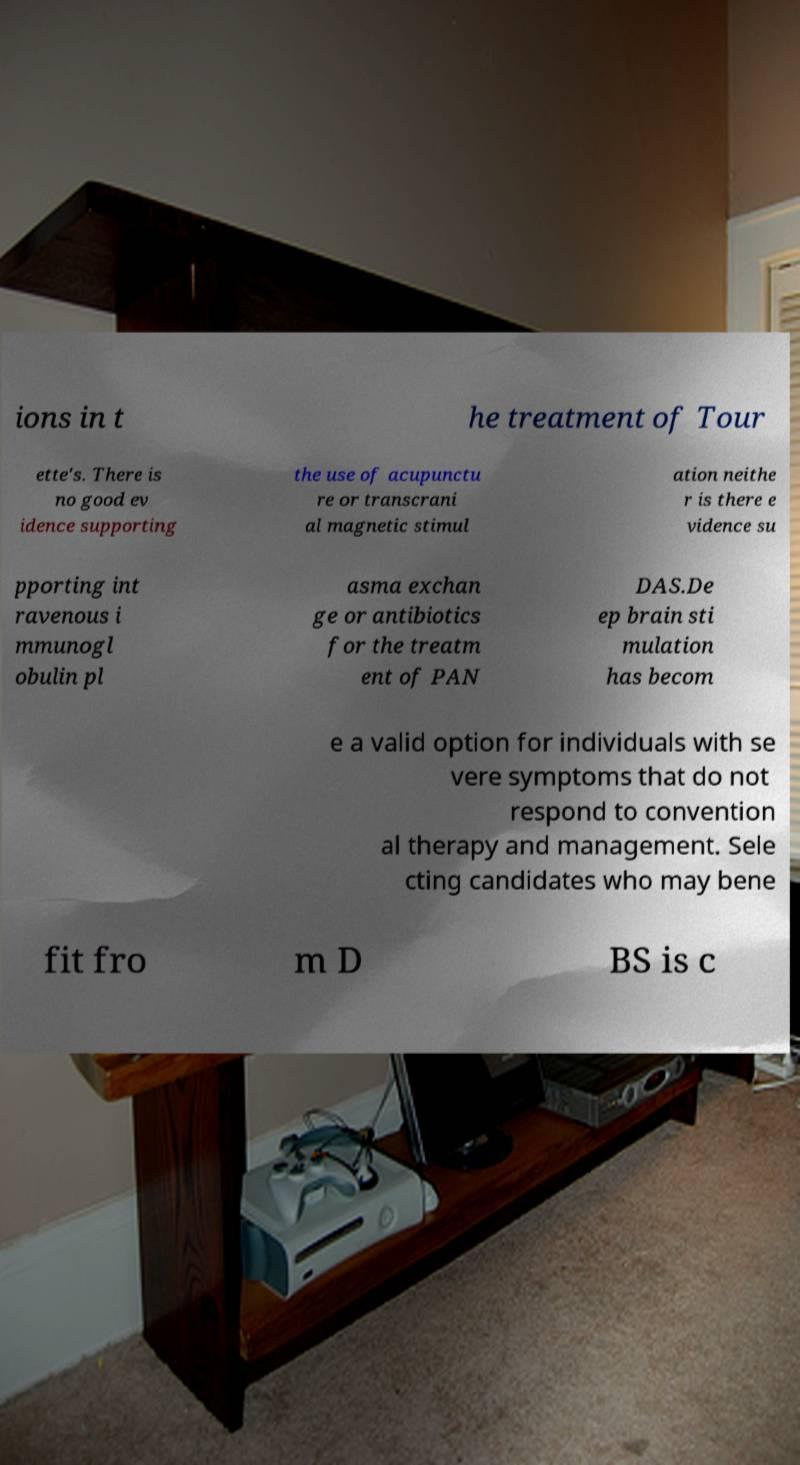Can you read and provide the text displayed in the image?This photo seems to have some interesting text. Can you extract and type it out for me? ions in t he treatment of Tour ette's. There is no good ev idence supporting the use of acupunctu re or transcrani al magnetic stimul ation neithe r is there e vidence su pporting int ravenous i mmunogl obulin pl asma exchan ge or antibiotics for the treatm ent of PAN DAS.De ep brain sti mulation has becom e a valid option for individuals with se vere symptoms that do not respond to convention al therapy and management. Sele cting candidates who may bene fit fro m D BS is c 